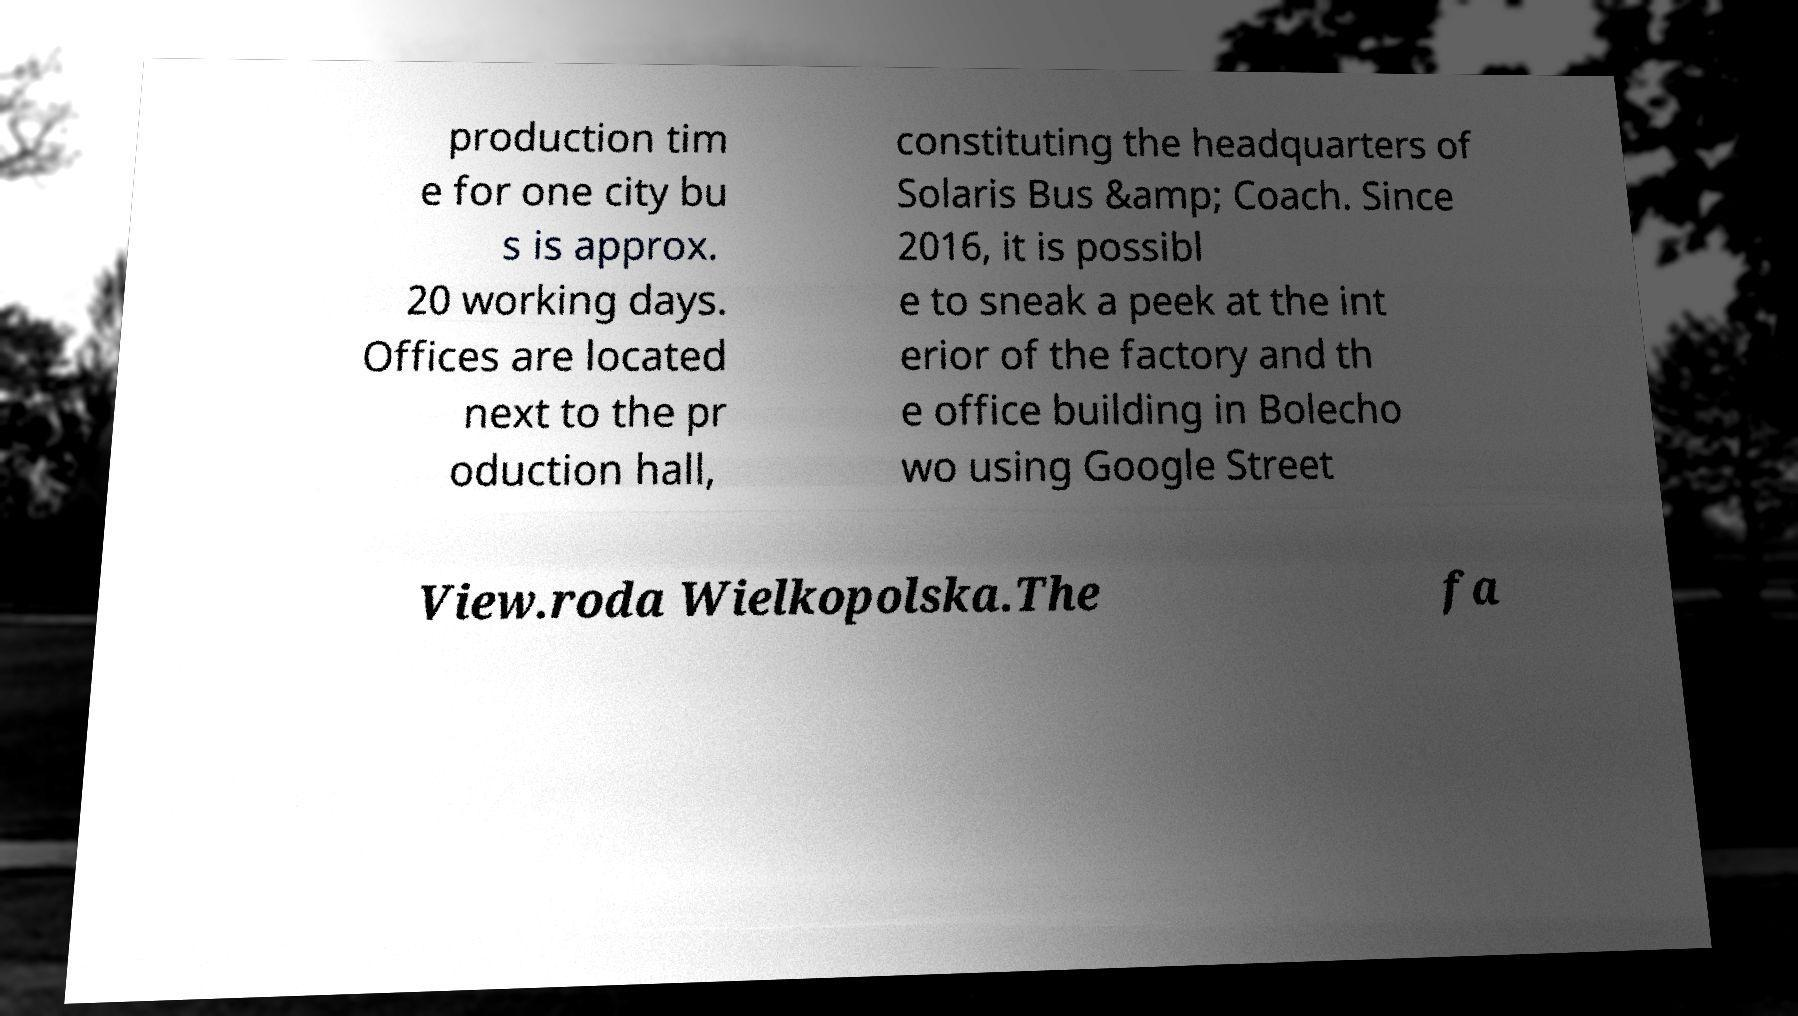Could you extract and type out the text from this image? production tim e for one city bu s is approx. 20 working days. Offices are located next to the pr oduction hall, constituting the headquarters of Solaris Bus &amp; Coach. Since 2016, it is possibl e to sneak a peek at the int erior of the factory and th e office building in Bolecho wo using Google Street View.roda Wielkopolska.The fa 